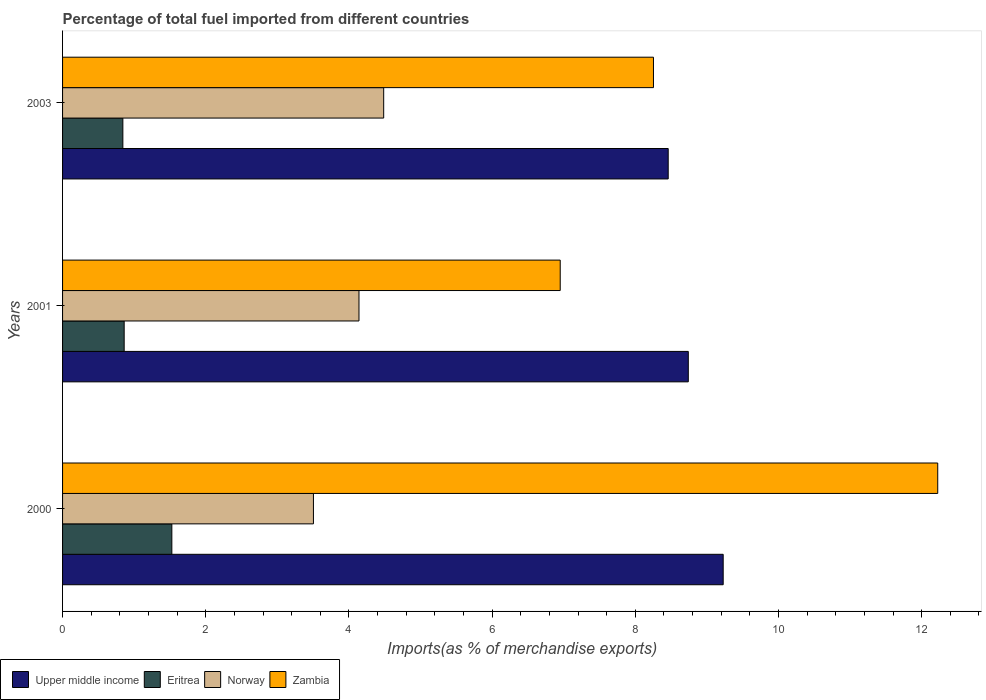Are the number of bars per tick equal to the number of legend labels?
Offer a terse response. Yes. Are the number of bars on each tick of the Y-axis equal?
Ensure brevity in your answer.  Yes. What is the label of the 2nd group of bars from the top?
Offer a terse response. 2001. In how many cases, is the number of bars for a given year not equal to the number of legend labels?
Ensure brevity in your answer.  0. What is the percentage of imports to different countries in Eritrea in 2000?
Provide a short and direct response. 1.53. Across all years, what is the maximum percentage of imports to different countries in Eritrea?
Your response must be concise. 1.53. Across all years, what is the minimum percentage of imports to different countries in Eritrea?
Your answer should be compact. 0.84. In which year was the percentage of imports to different countries in Zambia maximum?
Make the answer very short. 2000. What is the total percentage of imports to different countries in Upper middle income in the graph?
Give a very brief answer. 26.43. What is the difference between the percentage of imports to different countries in Zambia in 2001 and that in 2003?
Offer a very short reply. -1.3. What is the difference between the percentage of imports to different countries in Norway in 2000 and the percentage of imports to different countries in Zambia in 2003?
Offer a very short reply. -4.75. What is the average percentage of imports to different countries in Norway per year?
Your response must be concise. 4.04. In the year 2001, what is the difference between the percentage of imports to different countries in Norway and percentage of imports to different countries in Eritrea?
Offer a terse response. 3.28. What is the ratio of the percentage of imports to different countries in Eritrea in 2000 to that in 2001?
Keep it short and to the point. 1.77. Is the percentage of imports to different countries in Eritrea in 2000 less than that in 2001?
Give a very brief answer. No. Is the difference between the percentage of imports to different countries in Norway in 2001 and 2003 greater than the difference between the percentage of imports to different countries in Eritrea in 2001 and 2003?
Keep it short and to the point. No. What is the difference between the highest and the second highest percentage of imports to different countries in Eritrea?
Your answer should be compact. 0.67. What is the difference between the highest and the lowest percentage of imports to different countries in Norway?
Offer a very short reply. 0.98. Is the sum of the percentage of imports to different countries in Upper middle income in 2000 and 2003 greater than the maximum percentage of imports to different countries in Zambia across all years?
Provide a short and direct response. Yes. Is it the case that in every year, the sum of the percentage of imports to different countries in Norway and percentage of imports to different countries in Eritrea is greater than the sum of percentage of imports to different countries in Zambia and percentage of imports to different countries in Upper middle income?
Your answer should be compact. Yes. What does the 2nd bar from the top in 2000 represents?
Offer a very short reply. Norway. What does the 2nd bar from the bottom in 2001 represents?
Provide a short and direct response. Eritrea. Are all the bars in the graph horizontal?
Offer a terse response. Yes. How many years are there in the graph?
Your answer should be very brief. 3. What is the difference between two consecutive major ticks on the X-axis?
Provide a succinct answer. 2. Does the graph contain any zero values?
Offer a very short reply. No. Does the graph contain grids?
Your answer should be compact. No. How many legend labels are there?
Offer a terse response. 4. How are the legend labels stacked?
Keep it short and to the point. Horizontal. What is the title of the graph?
Your response must be concise. Percentage of total fuel imported from different countries. Does "Middle East & North Africa (developing only)" appear as one of the legend labels in the graph?
Make the answer very short. No. What is the label or title of the X-axis?
Offer a terse response. Imports(as % of merchandise exports). What is the label or title of the Y-axis?
Ensure brevity in your answer.  Years. What is the Imports(as % of merchandise exports) of Upper middle income in 2000?
Offer a very short reply. 9.23. What is the Imports(as % of merchandise exports) in Eritrea in 2000?
Offer a very short reply. 1.53. What is the Imports(as % of merchandise exports) of Norway in 2000?
Provide a succinct answer. 3.5. What is the Imports(as % of merchandise exports) of Zambia in 2000?
Provide a succinct answer. 12.22. What is the Imports(as % of merchandise exports) in Upper middle income in 2001?
Make the answer very short. 8.74. What is the Imports(as % of merchandise exports) in Eritrea in 2001?
Ensure brevity in your answer.  0.86. What is the Imports(as % of merchandise exports) in Norway in 2001?
Offer a very short reply. 4.14. What is the Imports(as % of merchandise exports) of Zambia in 2001?
Provide a succinct answer. 6.95. What is the Imports(as % of merchandise exports) in Upper middle income in 2003?
Ensure brevity in your answer.  8.46. What is the Imports(as % of merchandise exports) of Eritrea in 2003?
Offer a very short reply. 0.84. What is the Imports(as % of merchandise exports) of Norway in 2003?
Your answer should be compact. 4.49. What is the Imports(as % of merchandise exports) in Zambia in 2003?
Your response must be concise. 8.25. Across all years, what is the maximum Imports(as % of merchandise exports) of Upper middle income?
Your answer should be very brief. 9.23. Across all years, what is the maximum Imports(as % of merchandise exports) of Eritrea?
Provide a short and direct response. 1.53. Across all years, what is the maximum Imports(as % of merchandise exports) in Norway?
Provide a succinct answer. 4.49. Across all years, what is the maximum Imports(as % of merchandise exports) in Zambia?
Offer a terse response. 12.22. Across all years, what is the minimum Imports(as % of merchandise exports) of Upper middle income?
Provide a short and direct response. 8.46. Across all years, what is the minimum Imports(as % of merchandise exports) in Eritrea?
Your answer should be very brief. 0.84. Across all years, what is the minimum Imports(as % of merchandise exports) in Norway?
Your response must be concise. 3.5. Across all years, what is the minimum Imports(as % of merchandise exports) of Zambia?
Make the answer very short. 6.95. What is the total Imports(as % of merchandise exports) in Upper middle income in the graph?
Your answer should be compact. 26.43. What is the total Imports(as % of merchandise exports) in Eritrea in the graph?
Provide a short and direct response. 3.23. What is the total Imports(as % of merchandise exports) in Norway in the graph?
Offer a terse response. 12.13. What is the total Imports(as % of merchandise exports) in Zambia in the graph?
Offer a terse response. 27.43. What is the difference between the Imports(as % of merchandise exports) in Upper middle income in 2000 and that in 2001?
Make the answer very short. 0.49. What is the difference between the Imports(as % of merchandise exports) of Eritrea in 2000 and that in 2001?
Give a very brief answer. 0.67. What is the difference between the Imports(as % of merchandise exports) of Norway in 2000 and that in 2001?
Offer a terse response. -0.64. What is the difference between the Imports(as % of merchandise exports) of Zambia in 2000 and that in 2001?
Your answer should be compact. 5.27. What is the difference between the Imports(as % of merchandise exports) of Upper middle income in 2000 and that in 2003?
Your response must be concise. 0.77. What is the difference between the Imports(as % of merchandise exports) in Eritrea in 2000 and that in 2003?
Give a very brief answer. 0.68. What is the difference between the Imports(as % of merchandise exports) in Norway in 2000 and that in 2003?
Give a very brief answer. -0.98. What is the difference between the Imports(as % of merchandise exports) of Zambia in 2000 and that in 2003?
Provide a succinct answer. 3.97. What is the difference between the Imports(as % of merchandise exports) in Upper middle income in 2001 and that in 2003?
Provide a succinct answer. 0.28. What is the difference between the Imports(as % of merchandise exports) in Eritrea in 2001 and that in 2003?
Your answer should be very brief. 0.02. What is the difference between the Imports(as % of merchandise exports) in Norway in 2001 and that in 2003?
Provide a succinct answer. -0.34. What is the difference between the Imports(as % of merchandise exports) of Zambia in 2001 and that in 2003?
Your answer should be very brief. -1.3. What is the difference between the Imports(as % of merchandise exports) in Upper middle income in 2000 and the Imports(as % of merchandise exports) in Eritrea in 2001?
Give a very brief answer. 8.37. What is the difference between the Imports(as % of merchandise exports) in Upper middle income in 2000 and the Imports(as % of merchandise exports) in Norway in 2001?
Offer a very short reply. 5.09. What is the difference between the Imports(as % of merchandise exports) of Upper middle income in 2000 and the Imports(as % of merchandise exports) of Zambia in 2001?
Keep it short and to the point. 2.28. What is the difference between the Imports(as % of merchandise exports) in Eritrea in 2000 and the Imports(as % of merchandise exports) in Norway in 2001?
Offer a very short reply. -2.61. What is the difference between the Imports(as % of merchandise exports) of Eritrea in 2000 and the Imports(as % of merchandise exports) of Zambia in 2001?
Make the answer very short. -5.43. What is the difference between the Imports(as % of merchandise exports) of Norway in 2000 and the Imports(as % of merchandise exports) of Zambia in 2001?
Keep it short and to the point. -3.45. What is the difference between the Imports(as % of merchandise exports) of Upper middle income in 2000 and the Imports(as % of merchandise exports) of Eritrea in 2003?
Offer a terse response. 8.39. What is the difference between the Imports(as % of merchandise exports) of Upper middle income in 2000 and the Imports(as % of merchandise exports) of Norway in 2003?
Your answer should be compact. 4.74. What is the difference between the Imports(as % of merchandise exports) in Upper middle income in 2000 and the Imports(as % of merchandise exports) in Zambia in 2003?
Make the answer very short. 0.97. What is the difference between the Imports(as % of merchandise exports) of Eritrea in 2000 and the Imports(as % of merchandise exports) of Norway in 2003?
Your response must be concise. -2.96. What is the difference between the Imports(as % of merchandise exports) of Eritrea in 2000 and the Imports(as % of merchandise exports) of Zambia in 2003?
Your answer should be compact. -6.73. What is the difference between the Imports(as % of merchandise exports) in Norway in 2000 and the Imports(as % of merchandise exports) in Zambia in 2003?
Offer a terse response. -4.75. What is the difference between the Imports(as % of merchandise exports) in Upper middle income in 2001 and the Imports(as % of merchandise exports) in Eritrea in 2003?
Make the answer very short. 7.9. What is the difference between the Imports(as % of merchandise exports) of Upper middle income in 2001 and the Imports(as % of merchandise exports) of Norway in 2003?
Your answer should be very brief. 4.25. What is the difference between the Imports(as % of merchandise exports) of Upper middle income in 2001 and the Imports(as % of merchandise exports) of Zambia in 2003?
Provide a succinct answer. 0.49. What is the difference between the Imports(as % of merchandise exports) of Eritrea in 2001 and the Imports(as % of merchandise exports) of Norway in 2003?
Your response must be concise. -3.63. What is the difference between the Imports(as % of merchandise exports) of Eritrea in 2001 and the Imports(as % of merchandise exports) of Zambia in 2003?
Your answer should be compact. -7.39. What is the difference between the Imports(as % of merchandise exports) of Norway in 2001 and the Imports(as % of merchandise exports) of Zambia in 2003?
Offer a terse response. -4.11. What is the average Imports(as % of merchandise exports) in Upper middle income per year?
Ensure brevity in your answer.  8.81. What is the average Imports(as % of merchandise exports) of Eritrea per year?
Your response must be concise. 1.08. What is the average Imports(as % of merchandise exports) of Norway per year?
Your answer should be very brief. 4.04. What is the average Imports(as % of merchandise exports) of Zambia per year?
Your response must be concise. 9.14. In the year 2000, what is the difference between the Imports(as % of merchandise exports) of Upper middle income and Imports(as % of merchandise exports) of Eritrea?
Offer a terse response. 7.7. In the year 2000, what is the difference between the Imports(as % of merchandise exports) in Upper middle income and Imports(as % of merchandise exports) in Norway?
Ensure brevity in your answer.  5.72. In the year 2000, what is the difference between the Imports(as % of merchandise exports) in Upper middle income and Imports(as % of merchandise exports) in Zambia?
Offer a very short reply. -3. In the year 2000, what is the difference between the Imports(as % of merchandise exports) in Eritrea and Imports(as % of merchandise exports) in Norway?
Offer a terse response. -1.98. In the year 2000, what is the difference between the Imports(as % of merchandise exports) of Eritrea and Imports(as % of merchandise exports) of Zambia?
Your answer should be compact. -10.7. In the year 2000, what is the difference between the Imports(as % of merchandise exports) of Norway and Imports(as % of merchandise exports) of Zambia?
Make the answer very short. -8.72. In the year 2001, what is the difference between the Imports(as % of merchandise exports) of Upper middle income and Imports(as % of merchandise exports) of Eritrea?
Provide a succinct answer. 7.88. In the year 2001, what is the difference between the Imports(as % of merchandise exports) of Upper middle income and Imports(as % of merchandise exports) of Zambia?
Make the answer very short. 1.79. In the year 2001, what is the difference between the Imports(as % of merchandise exports) of Eritrea and Imports(as % of merchandise exports) of Norway?
Your response must be concise. -3.28. In the year 2001, what is the difference between the Imports(as % of merchandise exports) in Eritrea and Imports(as % of merchandise exports) in Zambia?
Provide a succinct answer. -6.09. In the year 2001, what is the difference between the Imports(as % of merchandise exports) of Norway and Imports(as % of merchandise exports) of Zambia?
Make the answer very short. -2.81. In the year 2003, what is the difference between the Imports(as % of merchandise exports) of Upper middle income and Imports(as % of merchandise exports) of Eritrea?
Ensure brevity in your answer.  7.62. In the year 2003, what is the difference between the Imports(as % of merchandise exports) in Upper middle income and Imports(as % of merchandise exports) in Norway?
Your answer should be very brief. 3.97. In the year 2003, what is the difference between the Imports(as % of merchandise exports) in Upper middle income and Imports(as % of merchandise exports) in Zambia?
Your answer should be very brief. 0.21. In the year 2003, what is the difference between the Imports(as % of merchandise exports) in Eritrea and Imports(as % of merchandise exports) in Norway?
Keep it short and to the point. -3.64. In the year 2003, what is the difference between the Imports(as % of merchandise exports) of Eritrea and Imports(as % of merchandise exports) of Zambia?
Provide a succinct answer. -7.41. In the year 2003, what is the difference between the Imports(as % of merchandise exports) in Norway and Imports(as % of merchandise exports) in Zambia?
Provide a short and direct response. -3.77. What is the ratio of the Imports(as % of merchandise exports) in Upper middle income in 2000 to that in 2001?
Keep it short and to the point. 1.06. What is the ratio of the Imports(as % of merchandise exports) of Eritrea in 2000 to that in 2001?
Keep it short and to the point. 1.77. What is the ratio of the Imports(as % of merchandise exports) in Norway in 2000 to that in 2001?
Keep it short and to the point. 0.85. What is the ratio of the Imports(as % of merchandise exports) of Zambia in 2000 to that in 2001?
Offer a terse response. 1.76. What is the ratio of the Imports(as % of merchandise exports) of Upper middle income in 2000 to that in 2003?
Provide a succinct answer. 1.09. What is the ratio of the Imports(as % of merchandise exports) in Eritrea in 2000 to that in 2003?
Provide a short and direct response. 1.81. What is the ratio of the Imports(as % of merchandise exports) of Norway in 2000 to that in 2003?
Keep it short and to the point. 0.78. What is the ratio of the Imports(as % of merchandise exports) of Zambia in 2000 to that in 2003?
Provide a short and direct response. 1.48. What is the ratio of the Imports(as % of merchandise exports) of Upper middle income in 2001 to that in 2003?
Keep it short and to the point. 1.03. What is the ratio of the Imports(as % of merchandise exports) in Eritrea in 2001 to that in 2003?
Your answer should be very brief. 1.02. What is the ratio of the Imports(as % of merchandise exports) in Norway in 2001 to that in 2003?
Offer a very short reply. 0.92. What is the ratio of the Imports(as % of merchandise exports) in Zambia in 2001 to that in 2003?
Provide a short and direct response. 0.84. What is the difference between the highest and the second highest Imports(as % of merchandise exports) of Upper middle income?
Provide a short and direct response. 0.49. What is the difference between the highest and the second highest Imports(as % of merchandise exports) in Eritrea?
Your answer should be very brief. 0.67. What is the difference between the highest and the second highest Imports(as % of merchandise exports) in Norway?
Provide a short and direct response. 0.34. What is the difference between the highest and the second highest Imports(as % of merchandise exports) of Zambia?
Make the answer very short. 3.97. What is the difference between the highest and the lowest Imports(as % of merchandise exports) of Upper middle income?
Provide a short and direct response. 0.77. What is the difference between the highest and the lowest Imports(as % of merchandise exports) in Eritrea?
Offer a terse response. 0.68. What is the difference between the highest and the lowest Imports(as % of merchandise exports) of Norway?
Make the answer very short. 0.98. What is the difference between the highest and the lowest Imports(as % of merchandise exports) of Zambia?
Offer a very short reply. 5.27. 